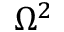Convert formula to latex. <formula><loc_0><loc_0><loc_500><loc_500>\Omega ^ { 2 }</formula> 